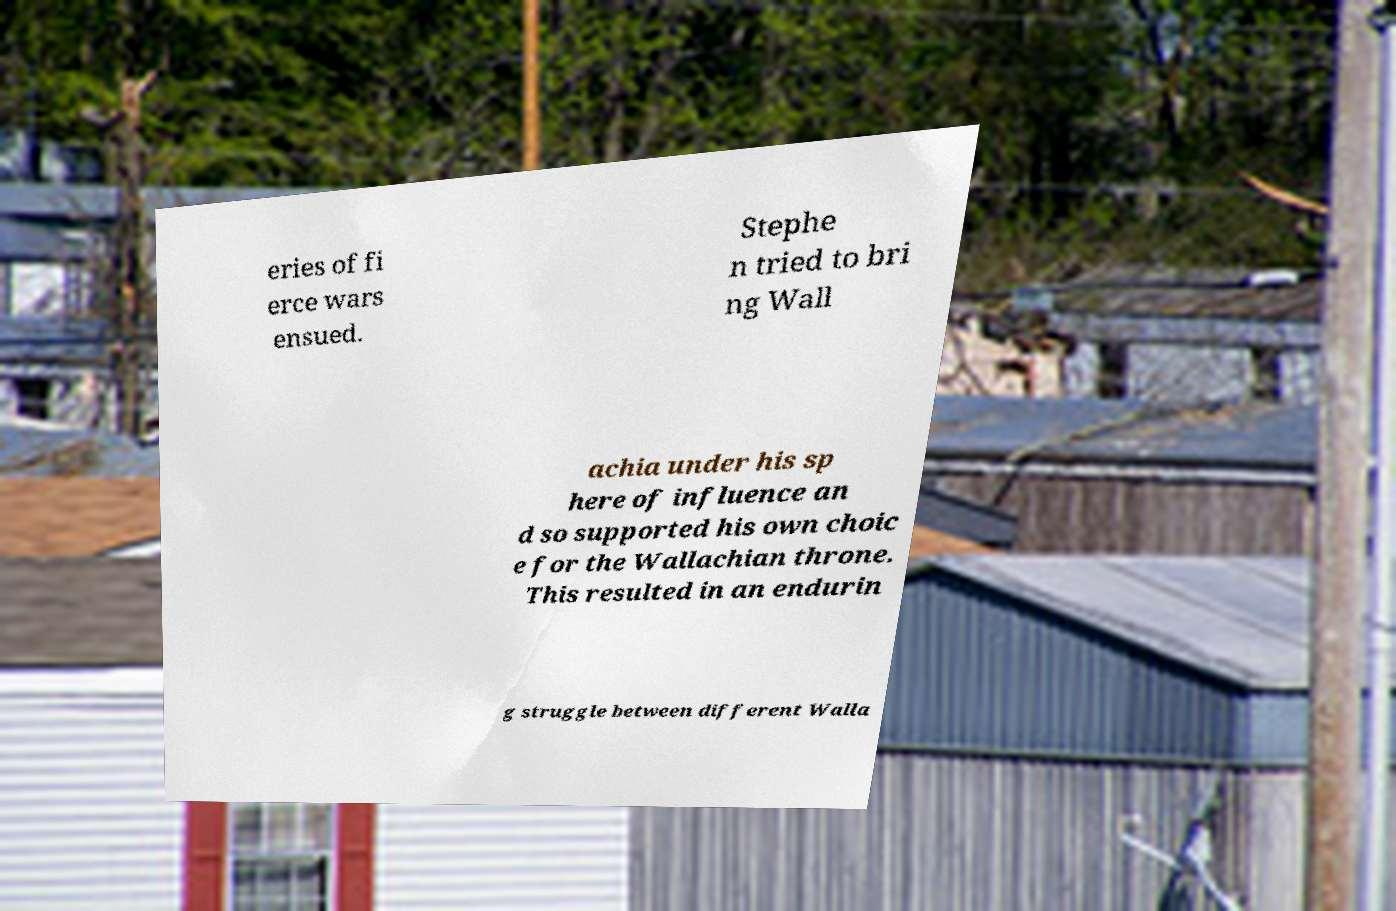Please read and relay the text visible in this image. What does it say? eries of fi erce wars ensued. Stephe n tried to bri ng Wall achia under his sp here of influence an d so supported his own choic e for the Wallachian throne. This resulted in an endurin g struggle between different Walla 